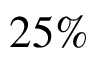Convert formula to latex. <formula><loc_0><loc_0><loc_500><loc_500>2 5 \%</formula> 